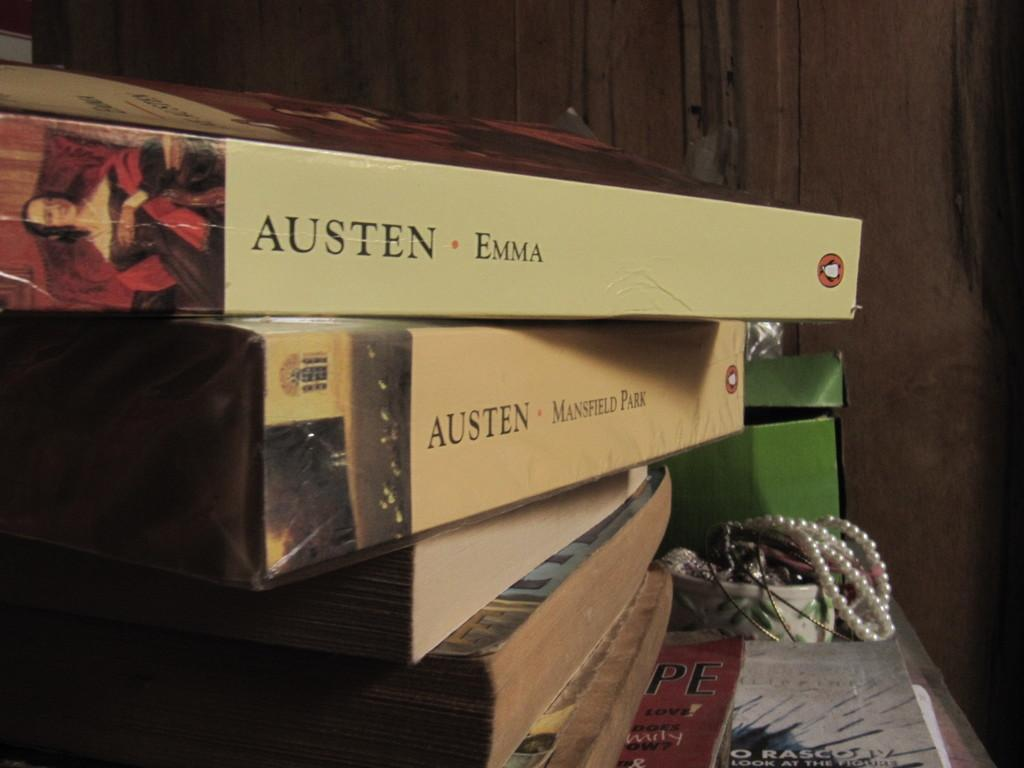<image>
Present a compact description of the photo's key features. Two great novels by the world famous Jane Austin. 